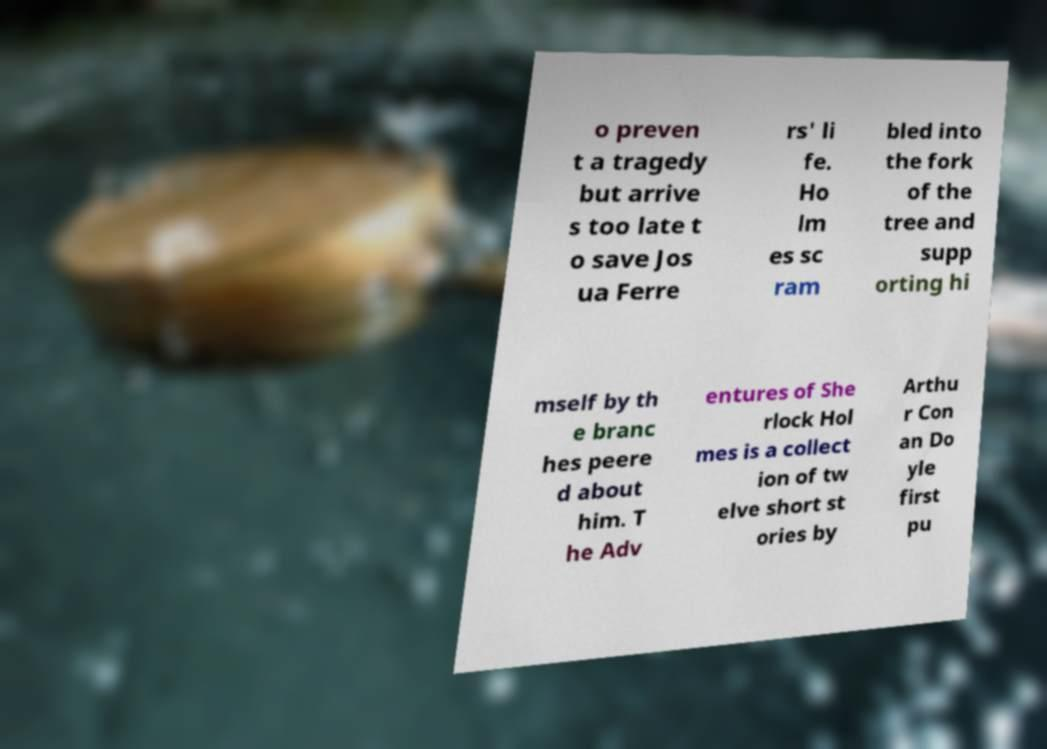Could you extract and type out the text from this image? o preven t a tragedy but arrive s too late t o save Jos ua Ferre rs' li fe. Ho lm es sc ram bled into the fork of the tree and supp orting hi mself by th e branc hes peere d about him. T he Adv entures of She rlock Hol mes is a collect ion of tw elve short st ories by Arthu r Con an Do yle first pu 